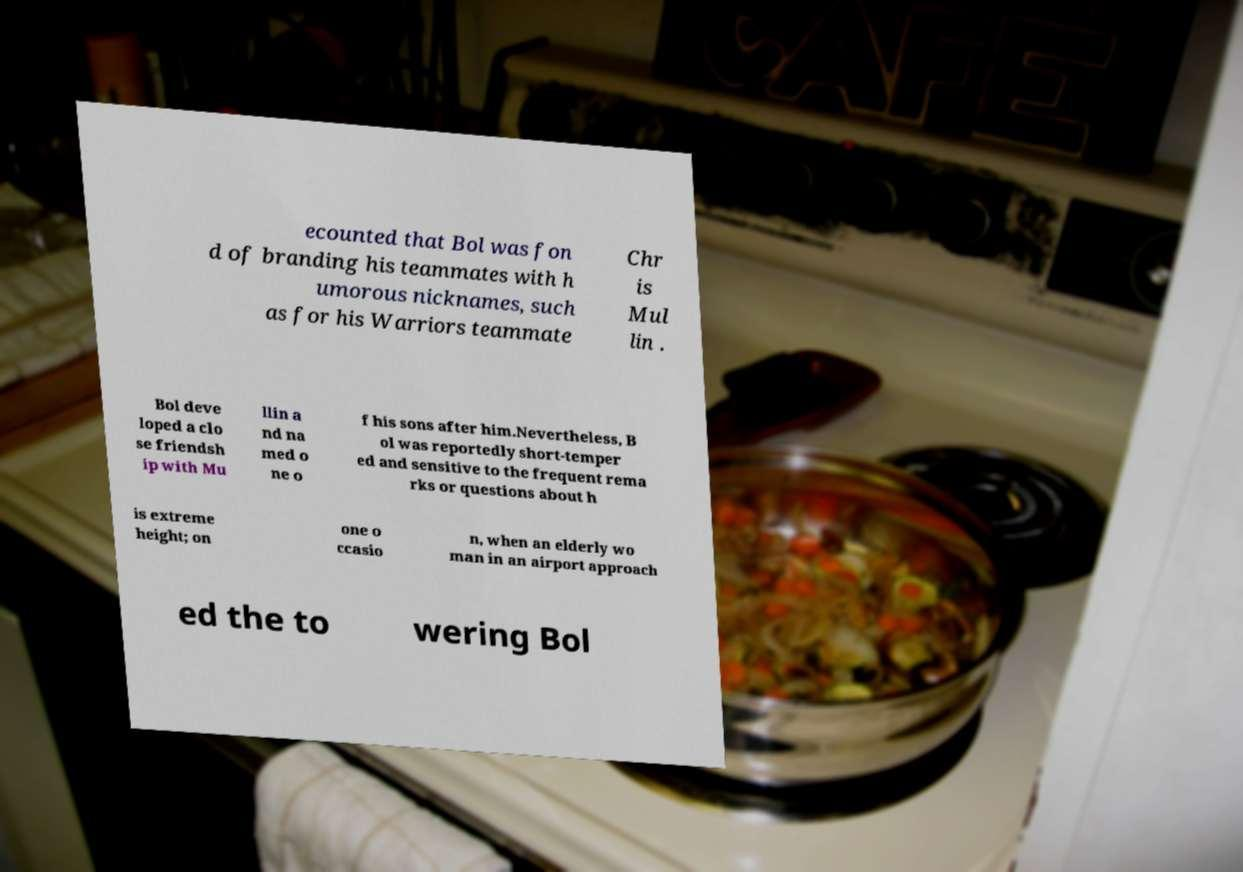Can you accurately transcribe the text from the provided image for me? ecounted that Bol was fon d of branding his teammates with h umorous nicknames, such as for his Warriors teammate Chr is Mul lin . Bol deve loped a clo se friendsh ip with Mu llin a nd na med o ne o f his sons after him.Nevertheless, B ol was reportedly short-temper ed and sensitive to the frequent rema rks or questions about h is extreme height; on one o ccasio n, when an elderly wo man in an airport approach ed the to wering Bol 